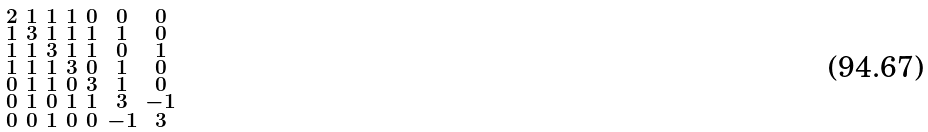<formula> <loc_0><loc_0><loc_500><loc_500>\begin{smallmatrix} 2 & 1 & 1 & 1 & 0 & 0 & 0 \\ 1 & 3 & 1 & 1 & 1 & 1 & 0 \\ 1 & 1 & 3 & 1 & 1 & 0 & 1 \\ 1 & 1 & 1 & 3 & 0 & 1 & 0 \\ 0 & 1 & 1 & 0 & 3 & 1 & 0 \\ 0 & 1 & 0 & 1 & 1 & 3 & - 1 \\ 0 & 0 & 1 & 0 & 0 & - 1 & 3 \end{smallmatrix}</formula> 